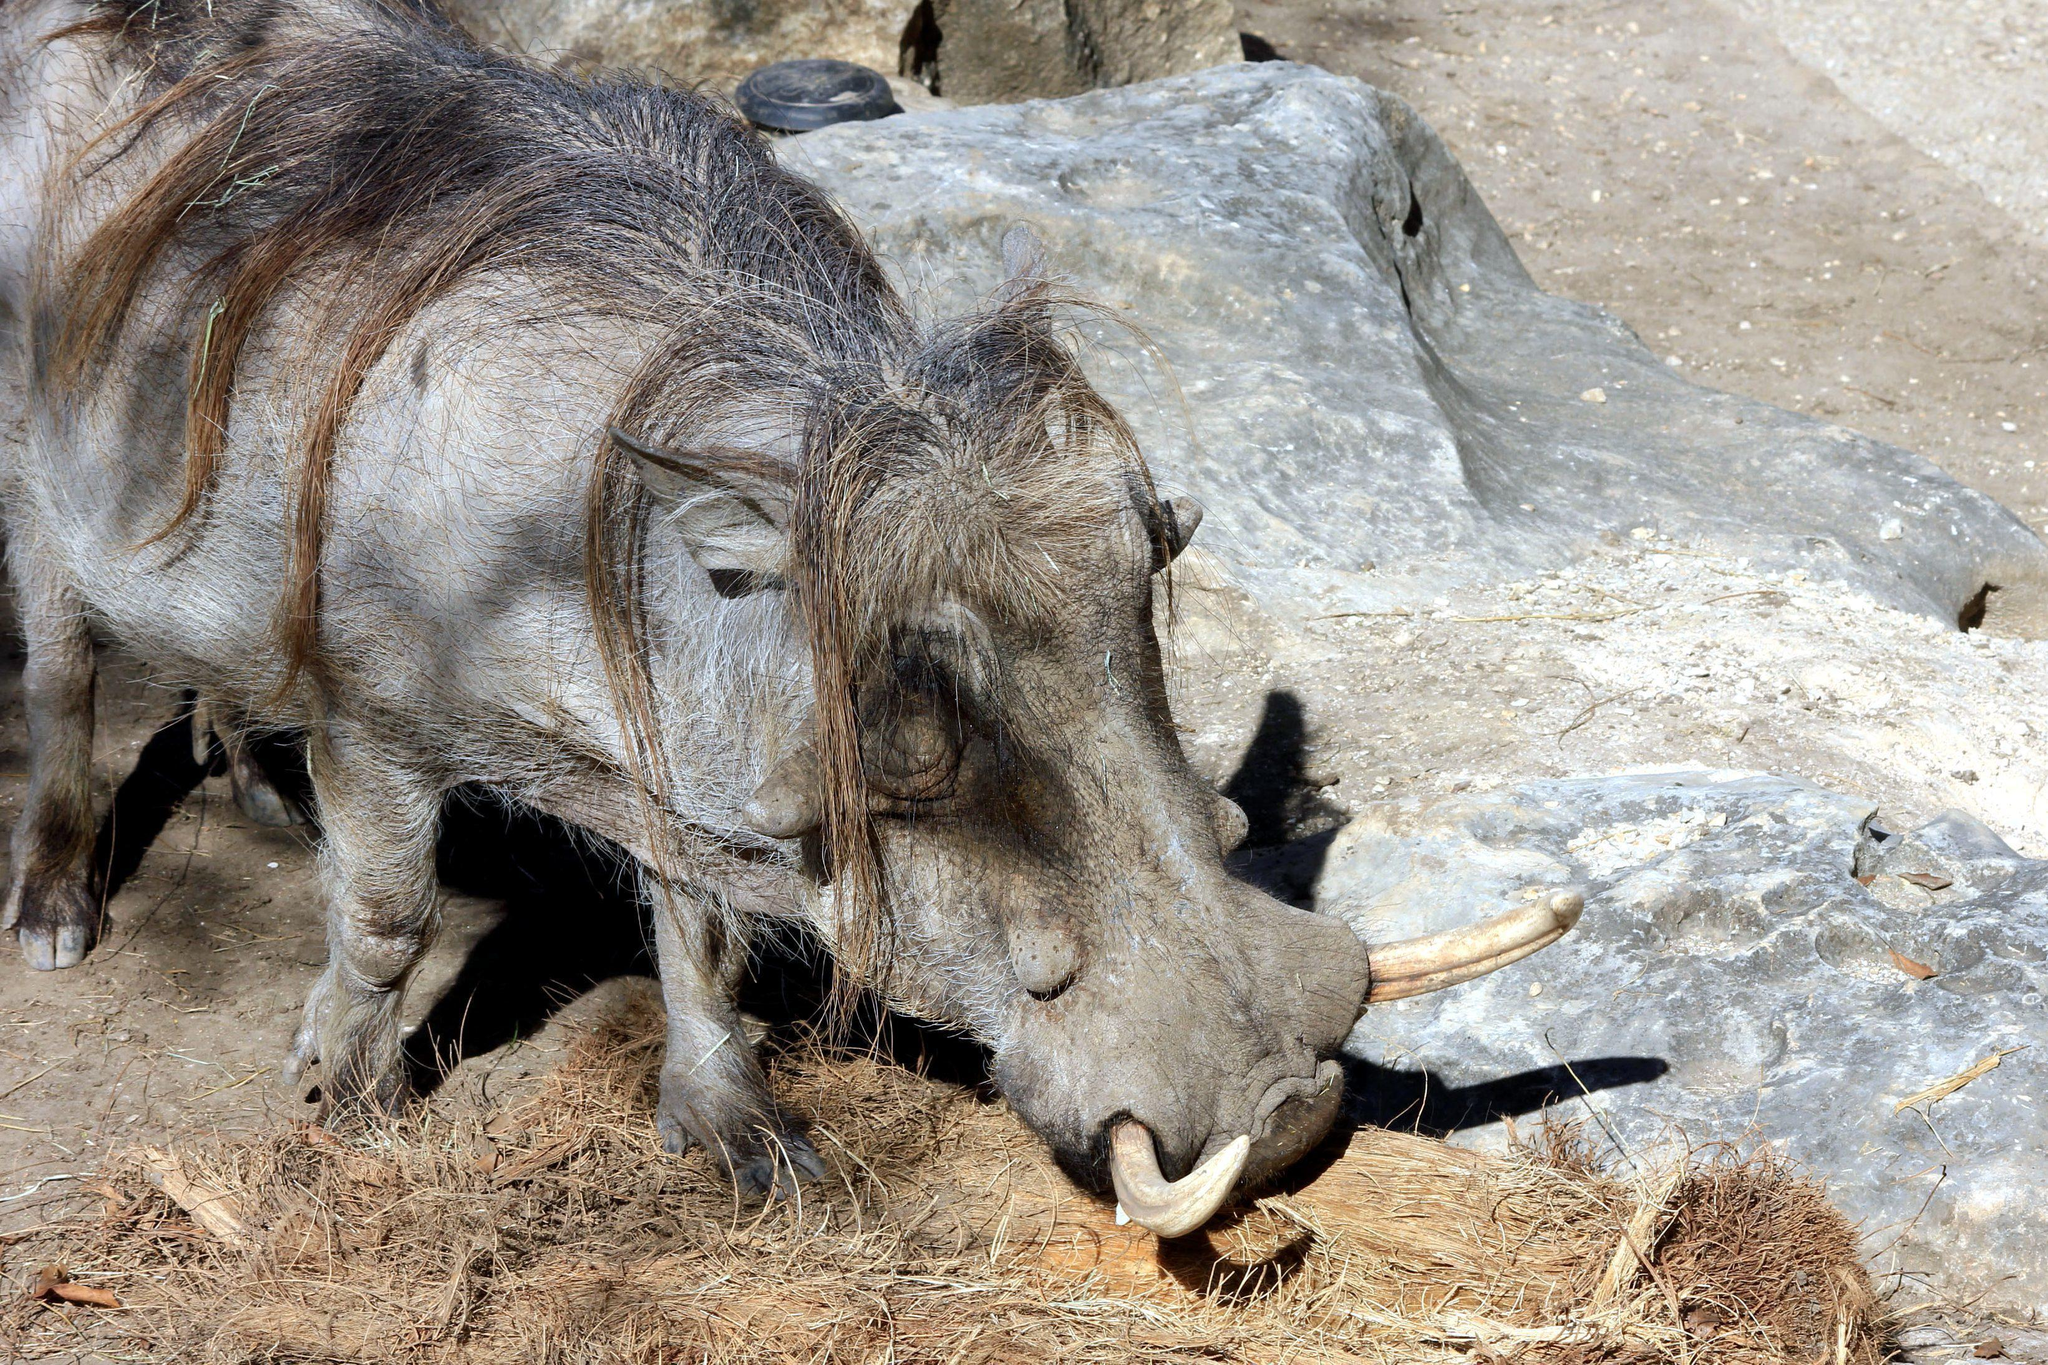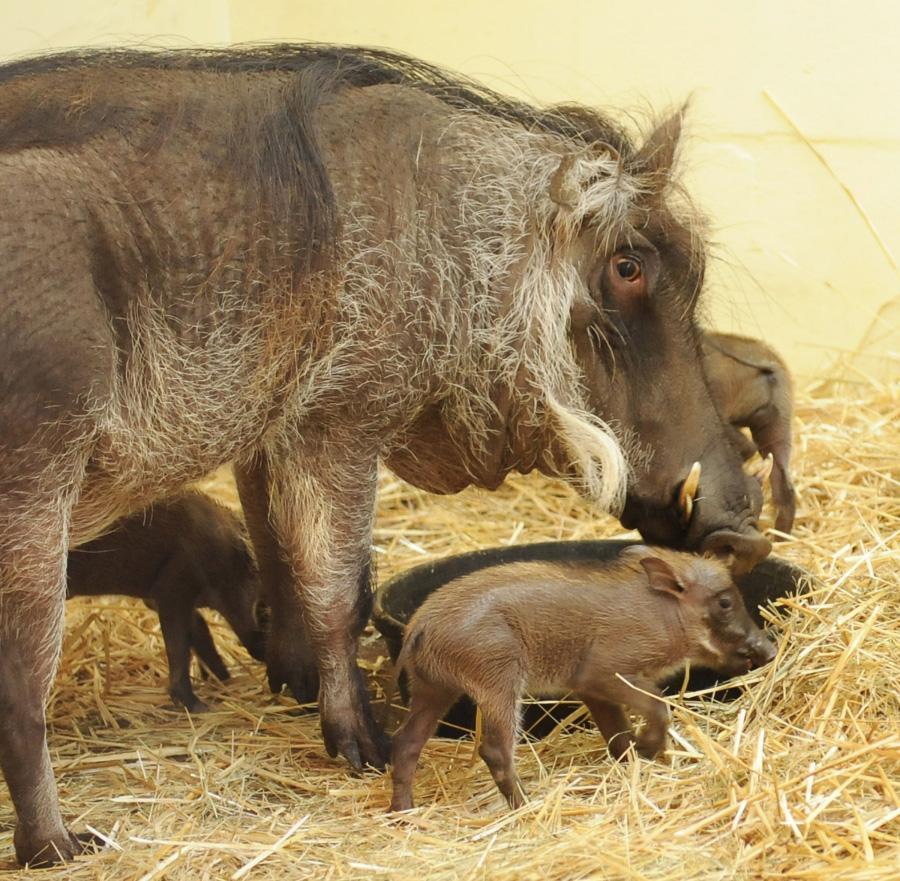The first image is the image on the left, the second image is the image on the right. Examine the images to the left and right. Is the description "There are at least two piglets lying down." accurate? Answer yes or no. No. The first image is the image on the left, the second image is the image on the right. Examine the images to the left and right. Is the description "Some baby pigs are cuddling near a wall." accurate? Answer yes or no. No. 